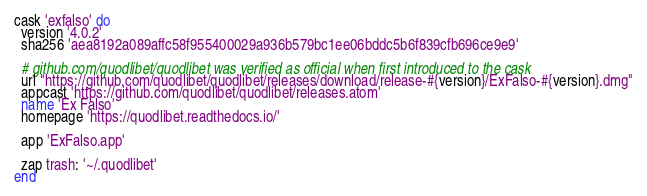<code> <loc_0><loc_0><loc_500><loc_500><_Ruby_>cask 'exfalso' do
  version '4.0.2'
  sha256 'aea8192a089affc58f955400029a936b579bc1ee06bddc5b6f839cfb696ce9e9'

  # github.com/quodlibet/quodlibet was verified as official when first introduced to the cask
  url "https://github.com/quodlibet/quodlibet/releases/download/release-#{version}/ExFalso-#{version}.dmg"
  appcast 'https://github.com/quodlibet/quodlibet/releases.atom'
  name 'Ex Falso'
  homepage 'https://quodlibet.readthedocs.io/'

  app 'ExFalso.app'

  zap trash: '~/.quodlibet'
end
</code> 